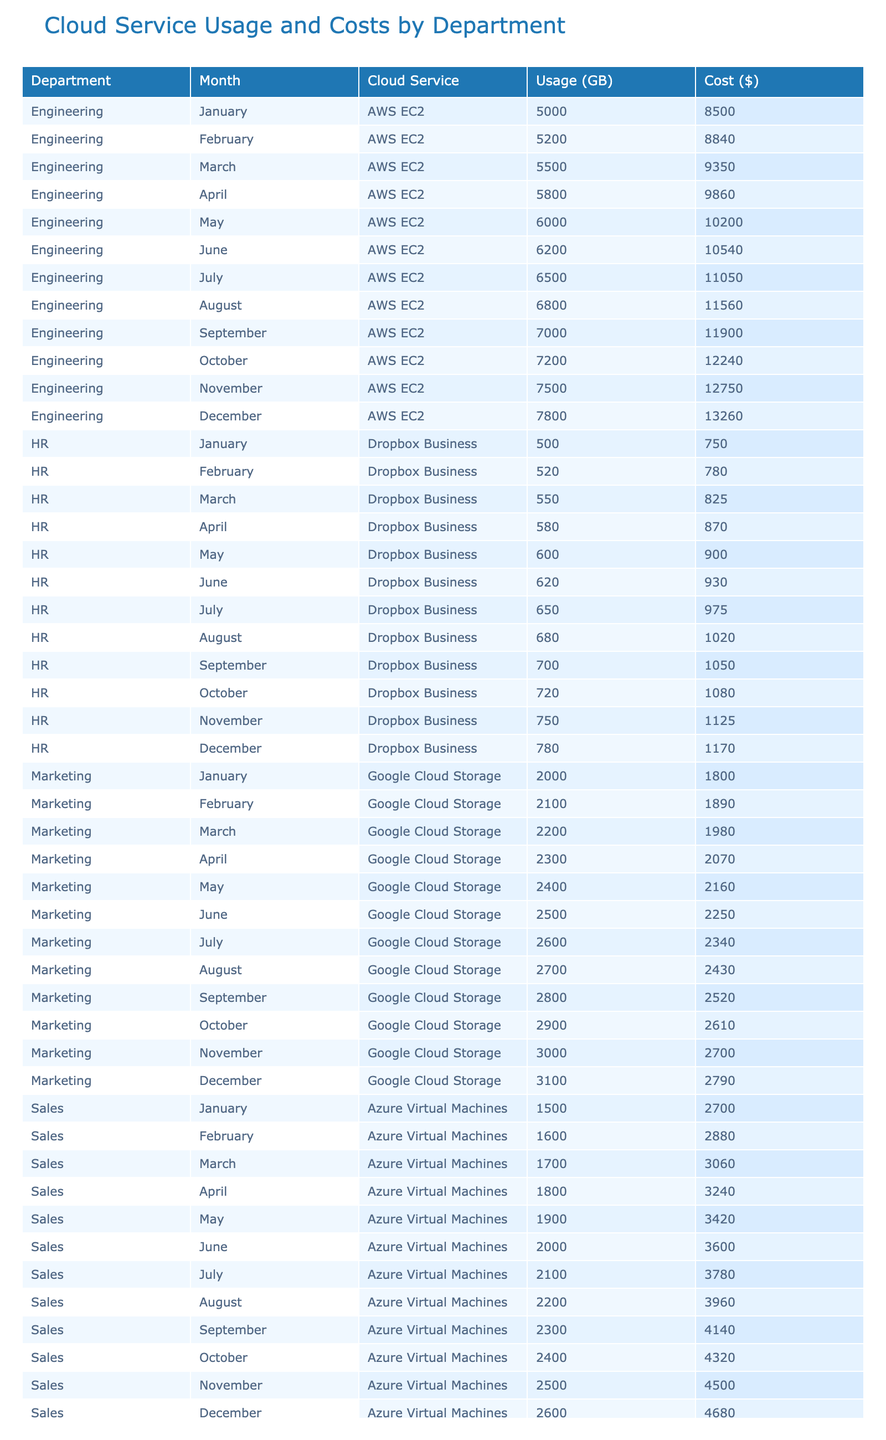What was the total cloud cost for the Engineering department in December? In December, the Engineering department's cost was $13,260.
Answer: $13,260 Which cloud service had the highest monthly cost in November? In November, the Engineering department's cost was $12,750, which is higher than the other departments' costs for the month.
Answer: AWS EC2 What is the average cost of cloud services used by the HR department over the entire year? The HR department's monthly costs were $750, $780, $825, $870, $900, $930, $975, $1020, $1050, $1080, $1125, and $1170. The total cost for HR is $11,700. Dividing this by 12 months gives an average of $975.
Answer: $975 Did the Marketing department's cloud usage increase every month? By comparing each month's usage for Marketing: January (2,000 GB), February (2,100 GB), March (2,200 GB), April (2,300 GB), May (2,400 GB), June (2,500 GB), July (2,600 GB), August (2,700 GB), September (2,800 GB), October (2,900 GB), November (3,000 GB), and December (3,100 GB), we see it did increase each month.
Answer: Yes What is the total cloud usage by the Sales department from January to June? Adding the monthly usage for the Sales department: 1,500 + 1,600 + 1,700 + 1,800 + 1,900 + 2,000 results in a total usage of 10,500 GB.
Answer: 10,500 GB Which department had the lowest cloud service cost in January? In January, the HR department had a cost of $750, which is lower than the costs for Engineering ($8,500), Marketing ($1,800), and Sales ($2,700).
Answer: HR What was the difference in total cloud usage between Engineering and Sales in July? In July, Engineering used 6,500 GB and Sales used 2,100 GB. The difference is 6,500 - 2,100 = 4,400 GB.
Answer: 4,400 GB How many monthly costs exceeded $10,000 for the Engineering department? The costs for Engineering were $8,500, $8,840, $9,350, $9,860, $10,200, $10,540, $11,050, $11,560, $11,900, $12,240, $12,750, and $13,260. Counting the months where costs were over $10,000 gives 6 months.
Answer: 6 What was the highest monthly cost for the Marketing department and in which month did it occur? The monthly costs for Marketing were $1,800, $1,890, $1,980, $2,070, $2,160, $2,250, $2,340, $2,430, $2,520, $2,610, $2,700, and $2,790. The highest was $2,790 in December.
Answer: $2,790 in December If we consider the average usage across all departments for August, what would that be? The usage for August across departments was: 6,800 (Engineering) + 2,700 (Marketing) + 2,200 (Sales) + 680 (HR) = 12,380 GB. Dividing by the 4 departments gives an average of 3,095 GB.
Answer: 3,095 GB 